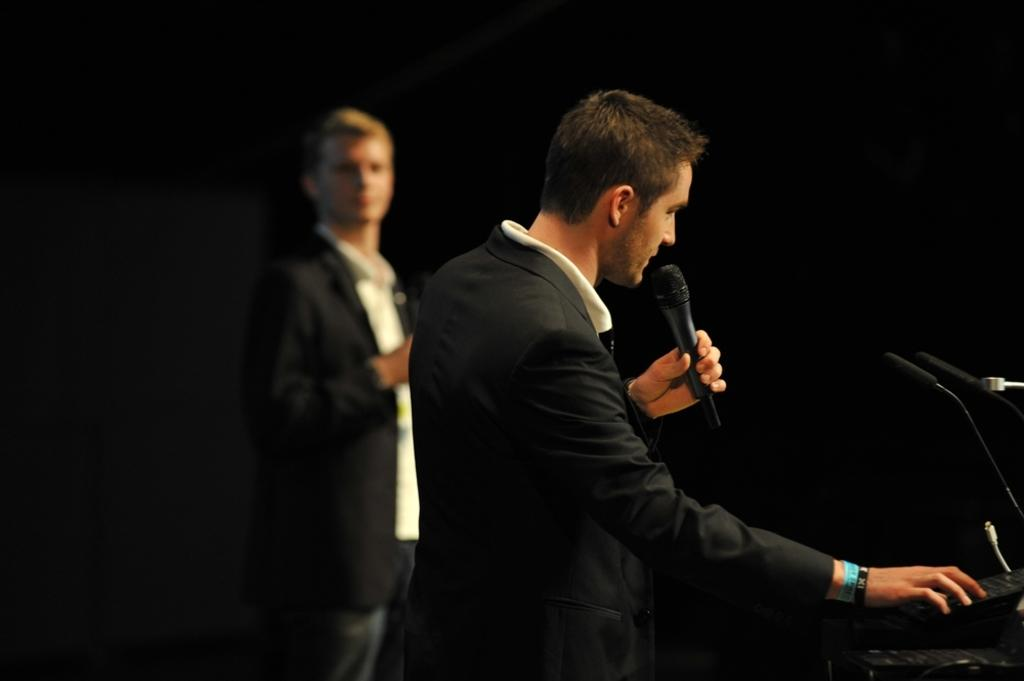How many people are in the image? There are two people in the image. What is one of the men holding in his hand? One man is holding a mic in his hand. Are there any other mics visible in the image? Yes, there are additional mics visible in the image. What type of ants can be seen crawling on the mics in the image? There are no ants present in the image, so it is not possible to determine what type of ants might be crawling on the mics. 